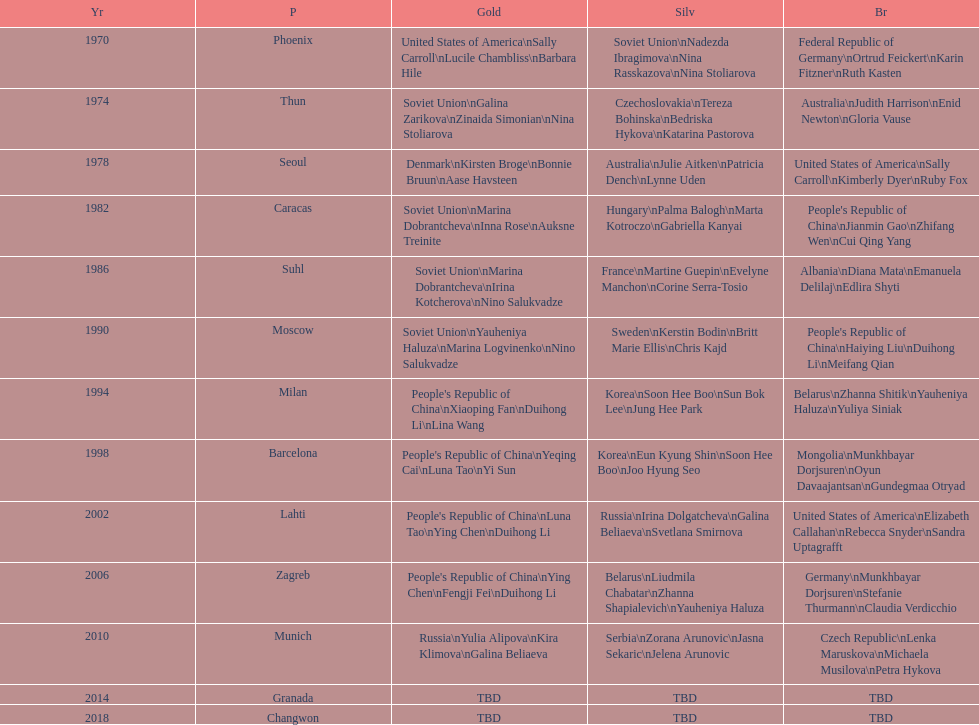Which country is listed the most under the silver column? Korea. 